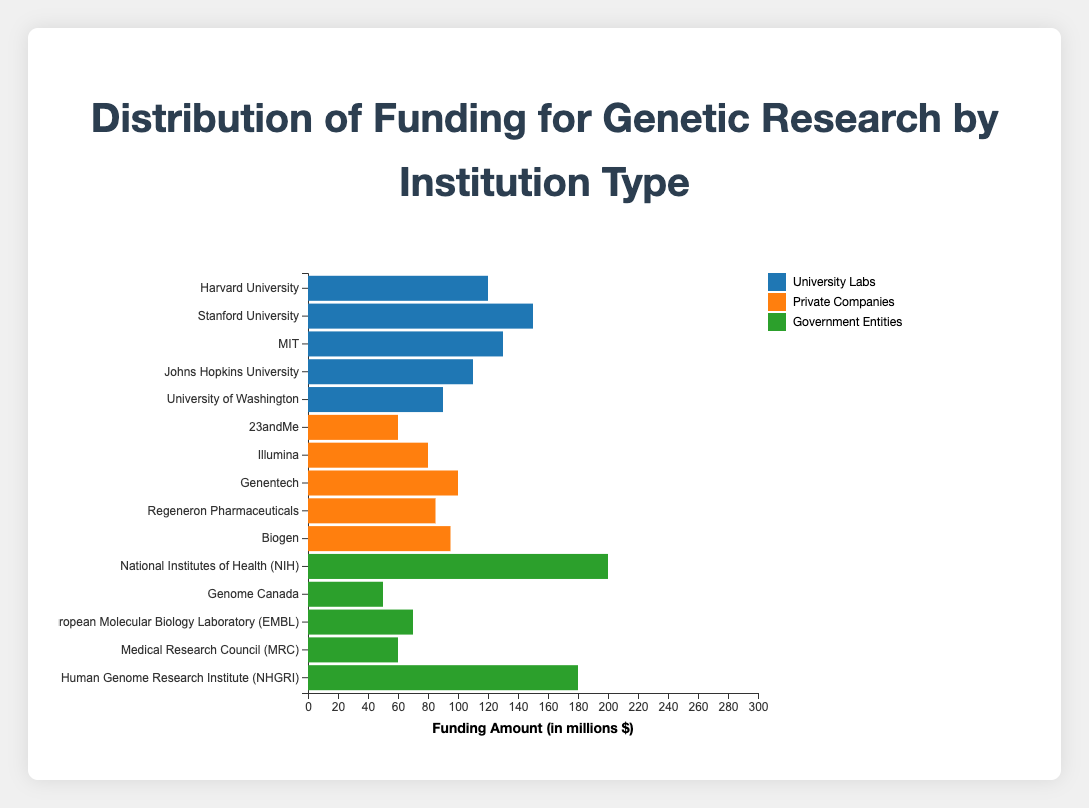What is the total funding amount for University Labs? Sum up the funding amounts for all the universities in "University Labs": 120 (Harvard) + 150 (Stanford) + 130 (MIT) + 110 (Johns Hopkins) + 90 (University of Washington) = 600
Answer: 600 Which institution type has the highest total funding? Calculate the total funding for each institution type. University Labs have 600, Private Companies have 420, and Government Entities have 560. The highest total funding is for University Labs
Answer: University Labs Which single entity received the most funding and how much? Among all institutions, the National Institutes of Health (NIH) received the highest funding amount of 200
Answer: National Institutes of Health (NIH), 200 Compare the funding for 23andMe and Illumina. Which one received more and by how much? 23andMe received 60 and Illumina received 80. The difference is 80 - 60 = 20, meaning Illumina received 20 more than 23andMe
Answer: Illumina, 20 What is the average funding amount for Government Entities? Government Entities' total funding is 560, divided by the 5 entities gives an average of 560 / 5 = 112
Answer: 112 Which institution type has the smallest total funding? Sum up the funding amounts for each type: University Labs 600, Private Companies 420, Government Entities 560. Private Companies have the smallest total funding of 420
Answer: Private Companies How does the funding for Harvard University compare with that for Johns Hopkins University? Harvard University received 120 while Johns Hopkins University received 110. Harvard University received 10 more than Johns Hopkins University
Answer: Harvard University, 10 Rank the funding amounts for the entities of University Labs from highest to lowest. Stanford University (150), MIT (130), Harvard University (120), Johns Hopkins University (110), University of Washington (90)
Answer: Stanford University, MIT, Harvard University, Johns Hopkins University, University of Washington How much more funding does the National Human Genome Research Institute (NHGRI) get compared to Genome Canada? NHGRI received 180 and Genome Canada received 50. The difference is 180 - 50 = 130
Answer: 130 